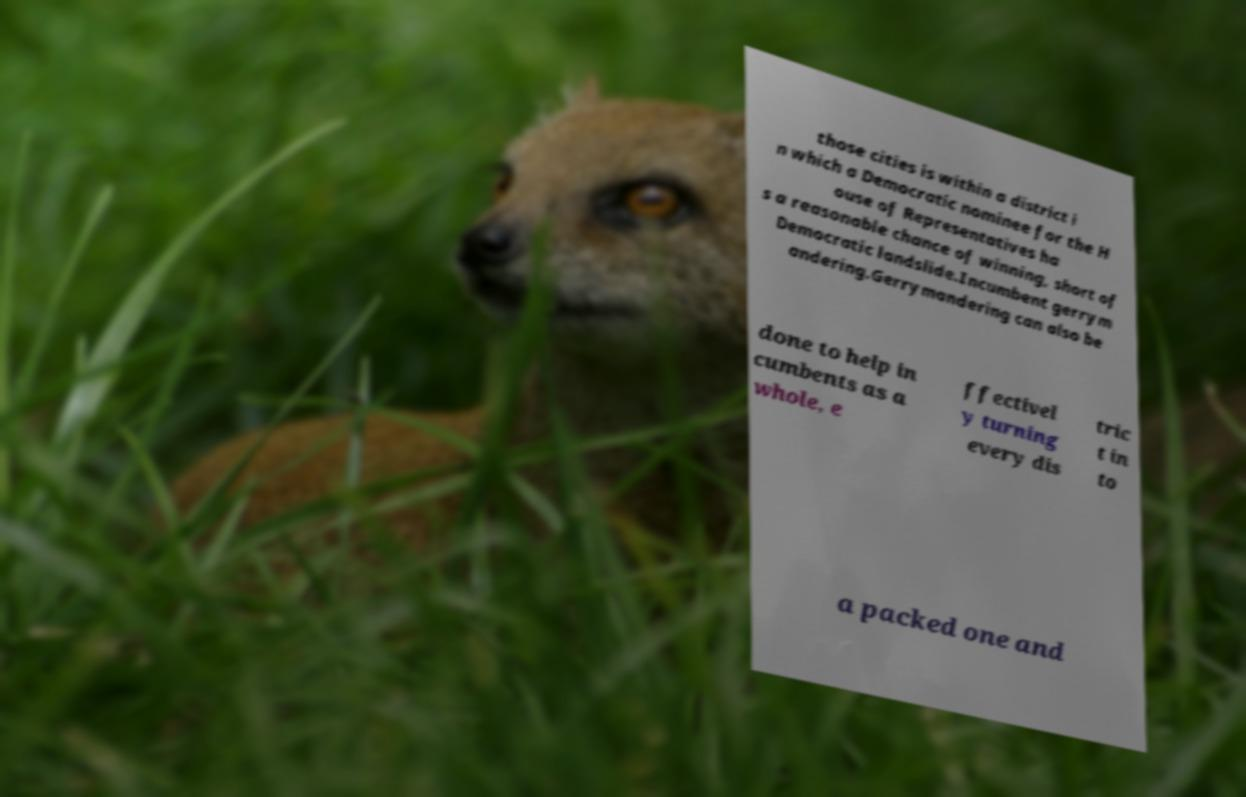For documentation purposes, I need the text within this image transcribed. Could you provide that? those cities is within a district i n which a Democratic nominee for the H ouse of Representatives ha s a reasonable chance of winning, short of Democratic landslide.Incumbent gerrym andering.Gerrymandering can also be done to help in cumbents as a whole, e ffectivel y turning every dis tric t in to a packed one and 